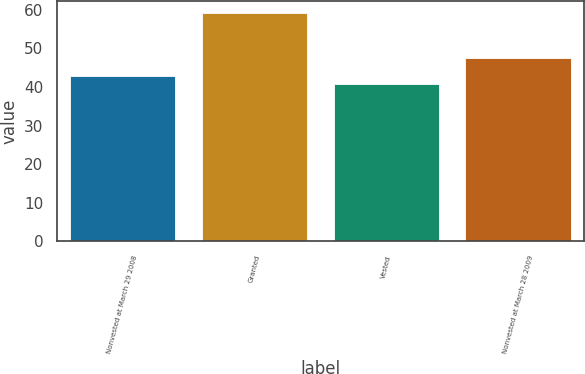<chart> <loc_0><loc_0><loc_500><loc_500><bar_chart><fcel>Nonvested at March 29 2008<fcel>Granted<fcel>Vested<fcel>Nonvested at March 28 2009<nl><fcel>42.7<fcel>59.22<fcel>40.86<fcel>47.58<nl></chart> 